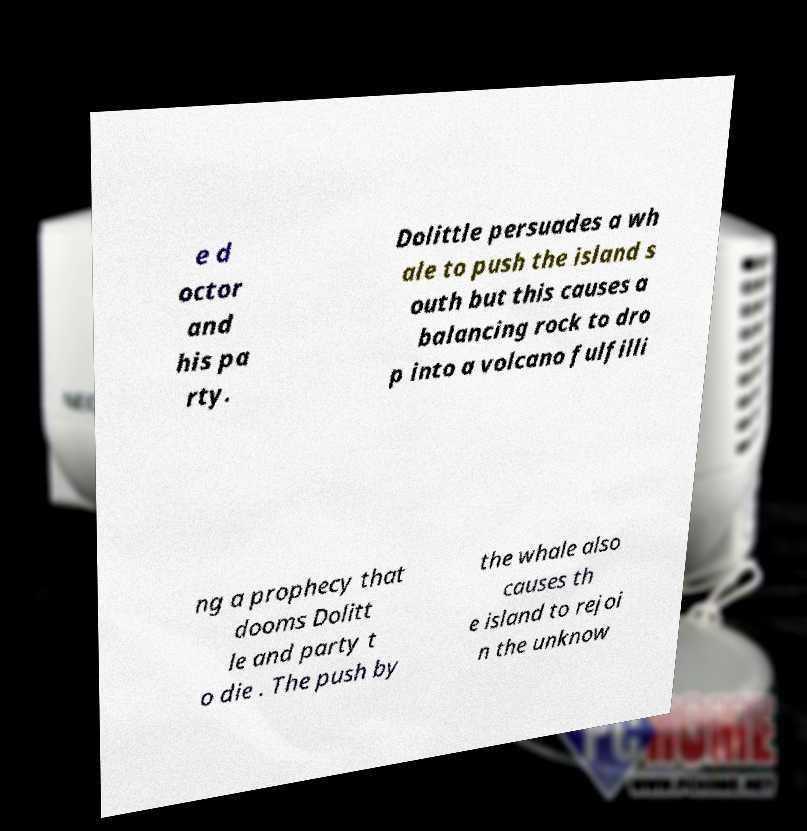Could you assist in decoding the text presented in this image and type it out clearly? e d octor and his pa rty. Dolittle persuades a wh ale to push the island s outh but this causes a balancing rock to dro p into a volcano fulfilli ng a prophecy that dooms Dolitt le and party t o die . The push by the whale also causes th e island to rejoi n the unknow 